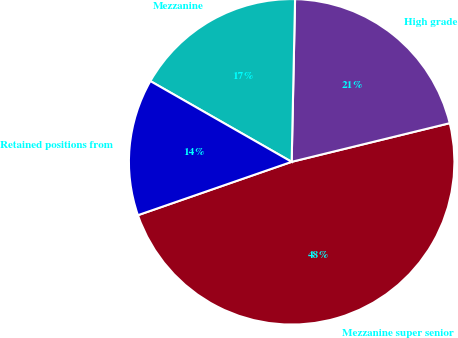Convert chart to OTSL. <chart><loc_0><loc_0><loc_500><loc_500><pie_chart><fcel>Mezzanine super senior<fcel>High grade<fcel>Mezzanine<fcel>Retained positions from<nl><fcel>48.5%<fcel>20.85%<fcel>17.07%<fcel>13.58%<nl></chart> 